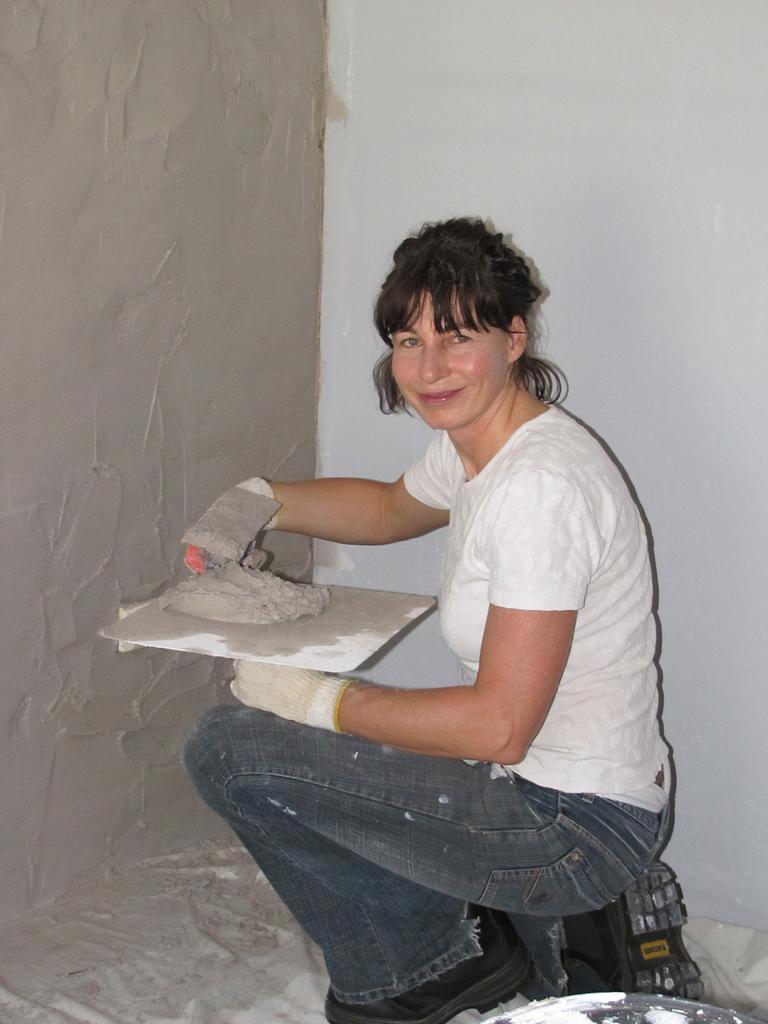Describe this image in one or two sentences. In this picture we can see a woman wearing white t-shirt, sitting in the front and holding the plaster in the hand. Behind we can see the plaster wall. 